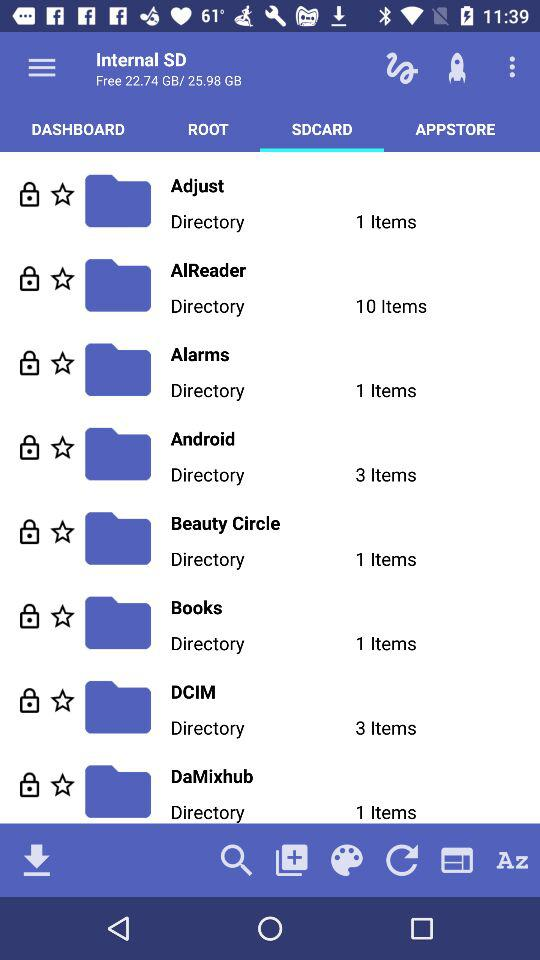Ten items are available in what directory? The directory is "AlReader". 